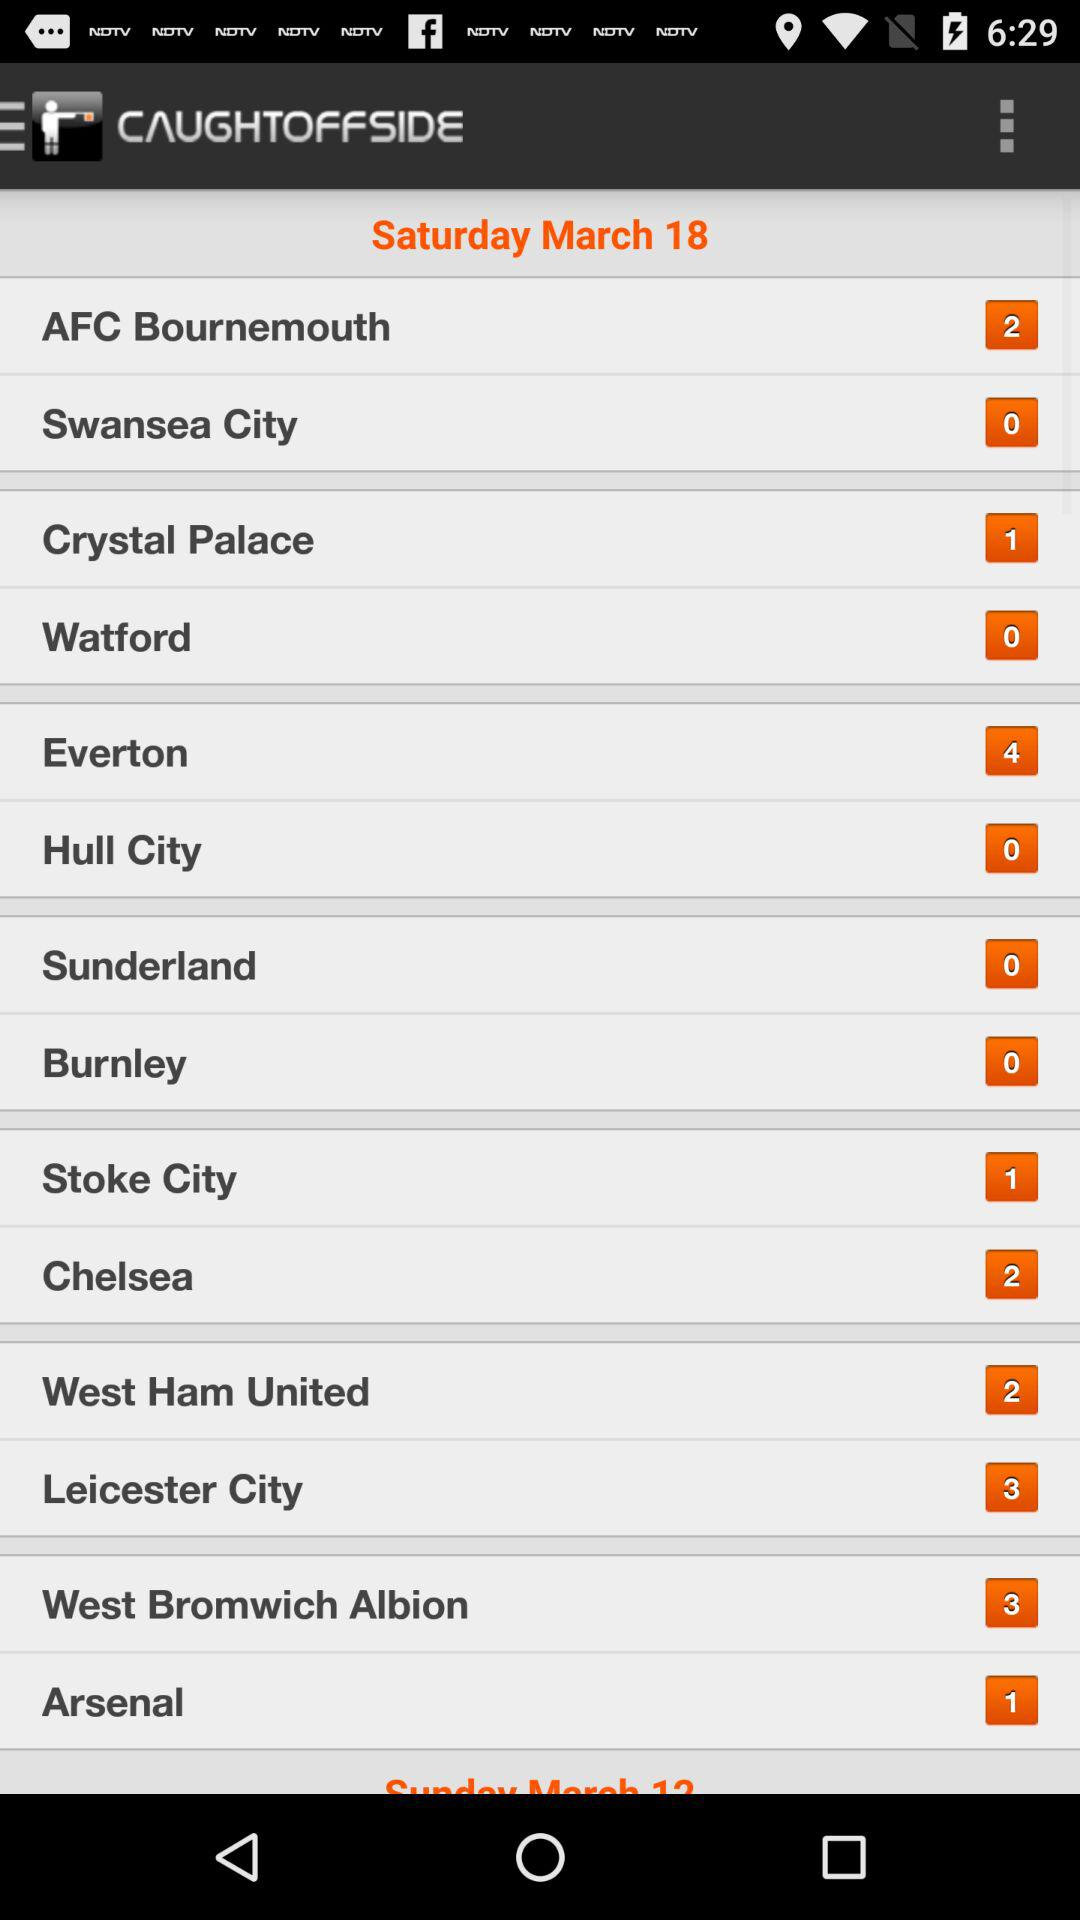What is the name of the application? The name of the application is "CAUGHTOFFSIDE". 